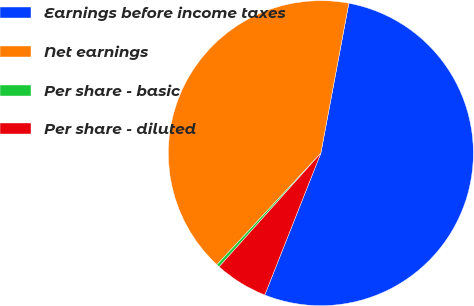<chart> <loc_0><loc_0><loc_500><loc_500><pie_chart><fcel>Earnings before income taxes<fcel>Net earnings<fcel>Per share - basic<fcel>Per share - diluted<nl><fcel>53.05%<fcel>41.0%<fcel>0.32%<fcel>5.63%<nl></chart> 